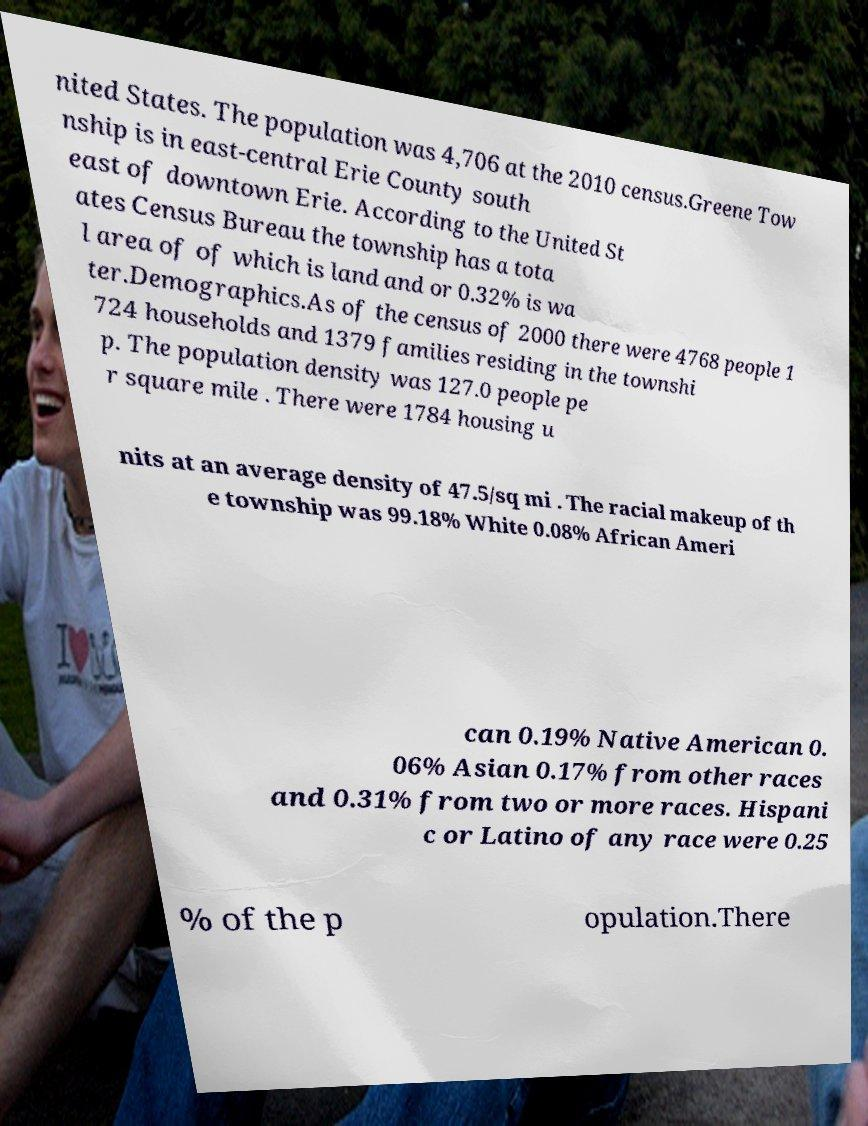Can you accurately transcribe the text from the provided image for me? nited States. The population was 4,706 at the 2010 census.Greene Tow nship is in east-central Erie County south east of downtown Erie. According to the United St ates Census Bureau the township has a tota l area of of which is land and or 0.32% is wa ter.Demographics.As of the census of 2000 there were 4768 people 1 724 households and 1379 families residing in the townshi p. The population density was 127.0 people pe r square mile . There were 1784 housing u nits at an average density of 47.5/sq mi . The racial makeup of th e township was 99.18% White 0.08% African Ameri can 0.19% Native American 0. 06% Asian 0.17% from other races and 0.31% from two or more races. Hispani c or Latino of any race were 0.25 % of the p opulation.There 